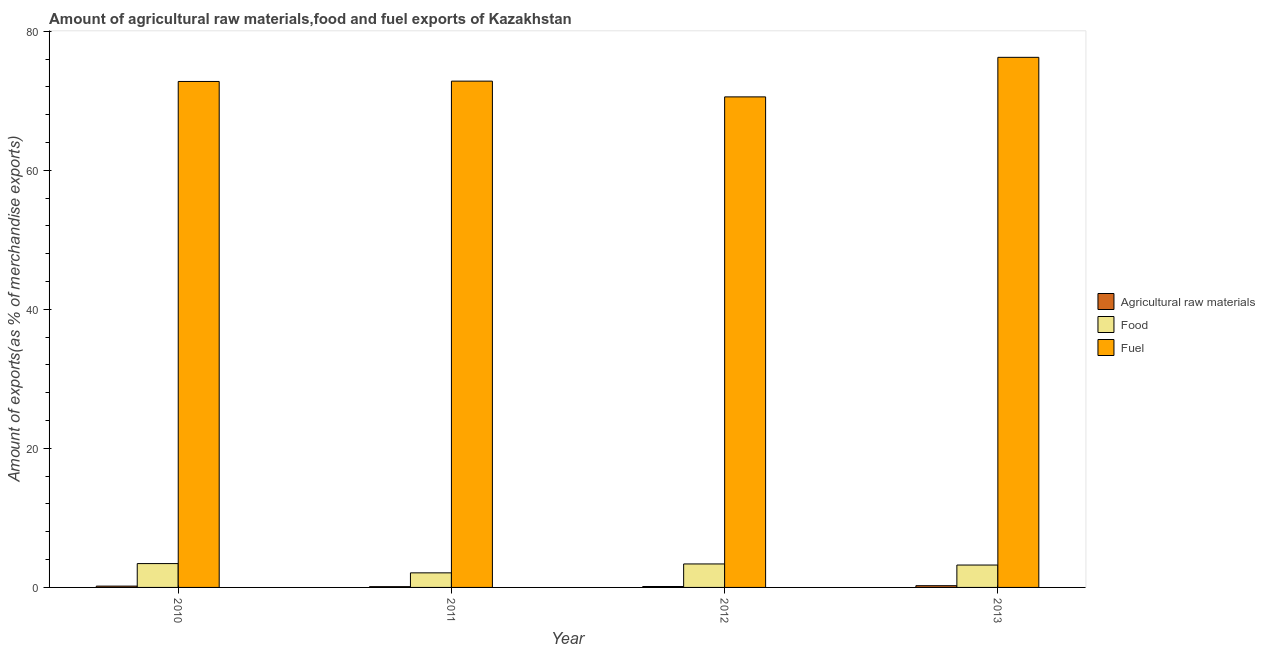How many different coloured bars are there?
Keep it short and to the point. 3. How many bars are there on the 3rd tick from the left?
Make the answer very short. 3. How many bars are there on the 3rd tick from the right?
Ensure brevity in your answer.  3. What is the percentage of food exports in 2012?
Provide a succinct answer. 3.38. Across all years, what is the maximum percentage of fuel exports?
Provide a succinct answer. 76.25. Across all years, what is the minimum percentage of food exports?
Make the answer very short. 2.1. In which year was the percentage of food exports maximum?
Your response must be concise. 2010. What is the total percentage of food exports in the graph?
Give a very brief answer. 12.12. What is the difference between the percentage of food exports in 2010 and that in 2013?
Keep it short and to the point. 0.21. What is the difference between the percentage of fuel exports in 2011 and the percentage of raw materials exports in 2012?
Your response must be concise. 2.27. What is the average percentage of food exports per year?
Provide a succinct answer. 3.03. In the year 2010, what is the difference between the percentage of fuel exports and percentage of raw materials exports?
Keep it short and to the point. 0. What is the ratio of the percentage of food exports in 2010 to that in 2011?
Offer a terse response. 1.64. Is the difference between the percentage of food exports in 2010 and 2013 greater than the difference between the percentage of fuel exports in 2010 and 2013?
Keep it short and to the point. No. What is the difference between the highest and the second highest percentage of food exports?
Your answer should be very brief. 0.05. What is the difference between the highest and the lowest percentage of fuel exports?
Give a very brief answer. 5.69. What does the 2nd bar from the left in 2010 represents?
Your response must be concise. Food. What does the 1st bar from the right in 2013 represents?
Make the answer very short. Fuel. Is it the case that in every year, the sum of the percentage of raw materials exports and percentage of food exports is greater than the percentage of fuel exports?
Your answer should be very brief. No. What is the difference between two consecutive major ticks on the Y-axis?
Your answer should be compact. 20. Are the values on the major ticks of Y-axis written in scientific E-notation?
Offer a terse response. No. Does the graph contain any zero values?
Ensure brevity in your answer.  No. Does the graph contain grids?
Keep it short and to the point. No. How are the legend labels stacked?
Your answer should be very brief. Vertical. What is the title of the graph?
Provide a short and direct response. Amount of agricultural raw materials,food and fuel exports of Kazakhstan. Does "Agricultural raw materials" appear as one of the legend labels in the graph?
Offer a terse response. Yes. What is the label or title of the X-axis?
Offer a very short reply. Year. What is the label or title of the Y-axis?
Offer a very short reply. Amount of exports(as % of merchandise exports). What is the Amount of exports(as % of merchandise exports) in Agricultural raw materials in 2010?
Ensure brevity in your answer.  0.19. What is the Amount of exports(as % of merchandise exports) in Food in 2010?
Give a very brief answer. 3.43. What is the Amount of exports(as % of merchandise exports) of Fuel in 2010?
Offer a terse response. 72.78. What is the Amount of exports(as % of merchandise exports) in Agricultural raw materials in 2011?
Your answer should be compact. 0.11. What is the Amount of exports(as % of merchandise exports) of Food in 2011?
Offer a very short reply. 2.1. What is the Amount of exports(as % of merchandise exports) in Fuel in 2011?
Give a very brief answer. 72.83. What is the Amount of exports(as % of merchandise exports) of Agricultural raw materials in 2012?
Your response must be concise. 0.13. What is the Amount of exports(as % of merchandise exports) in Food in 2012?
Your response must be concise. 3.38. What is the Amount of exports(as % of merchandise exports) of Fuel in 2012?
Offer a very short reply. 70.56. What is the Amount of exports(as % of merchandise exports) of Agricultural raw materials in 2013?
Your response must be concise. 0.25. What is the Amount of exports(as % of merchandise exports) in Food in 2013?
Your response must be concise. 3.22. What is the Amount of exports(as % of merchandise exports) of Fuel in 2013?
Provide a short and direct response. 76.25. Across all years, what is the maximum Amount of exports(as % of merchandise exports) in Agricultural raw materials?
Your answer should be very brief. 0.25. Across all years, what is the maximum Amount of exports(as % of merchandise exports) in Food?
Offer a terse response. 3.43. Across all years, what is the maximum Amount of exports(as % of merchandise exports) in Fuel?
Offer a terse response. 76.25. Across all years, what is the minimum Amount of exports(as % of merchandise exports) of Agricultural raw materials?
Provide a succinct answer. 0.11. Across all years, what is the minimum Amount of exports(as % of merchandise exports) of Food?
Offer a terse response. 2.1. Across all years, what is the minimum Amount of exports(as % of merchandise exports) in Fuel?
Your response must be concise. 70.56. What is the total Amount of exports(as % of merchandise exports) of Agricultural raw materials in the graph?
Keep it short and to the point. 0.68. What is the total Amount of exports(as % of merchandise exports) in Food in the graph?
Make the answer very short. 12.12. What is the total Amount of exports(as % of merchandise exports) in Fuel in the graph?
Your answer should be compact. 292.41. What is the difference between the Amount of exports(as % of merchandise exports) in Agricultural raw materials in 2010 and that in 2011?
Provide a succinct answer. 0.08. What is the difference between the Amount of exports(as % of merchandise exports) of Food in 2010 and that in 2011?
Your answer should be compact. 1.33. What is the difference between the Amount of exports(as % of merchandise exports) of Fuel in 2010 and that in 2011?
Offer a very short reply. -0.05. What is the difference between the Amount of exports(as % of merchandise exports) in Agricultural raw materials in 2010 and that in 2012?
Keep it short and to the point. 0.06. What is the difference between the Amount of exports(as % of merchandise exports) in Food in 2010 and that in 2012?
Offer a very short reply. 0.05. What is the difference between the Amount of exports(as % of merchandise exports) of Fuel in 2010 and that in 2012?
Ensure brevity in your answer.  2.22. What is the difference between the Amount of exports(as % of merchandise exports) in Agricultural raw materials in 2010 and that in 2013?
Keep it short and to the point. -0.06. What is the difference between the Amount of exports(as % of merchandise exports) in Food in 2010 and that in 2013?
Your response must be concise. 0.21. What is the difference between the Amount of exports(as % of merchandise exports) in Fuel in 2010 and that in 2013?
Offer a terse response. -3.47. What is the difference between the Amount of exports(as % of merchandise exports) in Agricultural raw materials in 2011 and that in 2012?
Give a very brief answer. -0.02. What is the difference between the Amount of exports(as % of merchandise exports) of Food in 2011 and that in 2012?
Your response must be concise. -1.28. What is the difference between the Amount of exports(as % of merchandise exports) of Fuel in 2011 and that in 2012?
Your response must be concise. 2.27. What is the difference between the Amount of exports(as % of merchandise exports) in Agricultural raw materials in 2011 and that in 2013?
Make the answer very short. -0.14. What is the difference between the Amount of exports(as % of merchandise exports) of Food in 2011 and that in 2013?
Make the answer very short. -1.12. What is the difference between the Amount of exports(as % of merchandise exports) of Fuel in 2011 and that in 2013?
Your answer should be compact. -3.42. What is the difference between the Amount of exports(as % of merchandise exports) in Agricultural raw materials in 2012 and that in 2013?
Give a very brief answer. -0.12. What is the difference between the Amount of exports(as % of merchandise exports) in Food in 2012 and that in 2013?
Give a very brief answer. 0.16. What is the difference between the Amount of exports(as % of merchandise exports) in Fuel in 2012 and that in 2013?
Ensure brevity in your answer.  -5.69. What is the difference between the Amount of exports(as % of merchandise exports) in Agricultural raw materials in 2010 and the Amount of exports(as % of merchandise exports) in Food in 2011?
Provide a short and direct response. -1.91. What is the difference between the Amount of exports(as % of merchandise exports) of Agricultural raw materials in 2010 and the Amount of exports(as % of merchandise exports) of Fuel in 2011?
Your answer should be compact. -72.64. What is the difference between the Amount of exports(as % of merchandise exports) of Food in 2010 and the Amount of exports(as % of merchandise exports) of Fuel in 2011?
Keep it short and to the point. -69.4. What is the difference between the Amount of exports(as % of merchandise exports) in Agricultural raw materials in 2010 and the Amount of exports(as % of merchandise exports) in Food in 2012?
Ensure brevity in your answer.  -3.19. What is the difference between the Amount of exports(as % of merchandise exports) of Agricultural raw materials in 2010 and the Amount of exports(as % of merchandise exports) of Fuel in 2012?
Make the answer very short. -70.37. What is the difference between the Amount of exports(as % of merchandise exports) in Food in 2010 and the Amount of exports(as % of merchandise exports) in Fuel in 2012?
Offer a very short reply. -67.13. What is the difference between the Amount of exports(as % of merchandise exports) in Agricultural raw materials in 2010 and the Amount of exports(as % of merchandise exports) in Food in 2013?
Ensure brevity in your answer.  -3.03. What is the difference between the Amount of exports(as % of merchandise exports) in Agricultural raw materials in 2010 and the Amount of exports(as % of merchandise exports) in Fuel in 2013?
Your response must be concise. -76.06. What is the difference between the Amount of exports(as % of merchandise exports) in Food in 2010 and the Amount of exports(as % of merchandise exports) in Fuel in 2013?
Make the answer very short. -72.82. What is the difference between the Amount of exports(as % of merchandise exports) in Agricultural raw materials in 2011 and the Amount of exports(as % of merchandise exports) in Food in 2012?
Provide a succinct answer. -3.27. What is the difference between the Amount of exports(as % of merchandise exports) in Agricultural raw materials in 2011 and the Amount of exports(as % of merchandise exports) in Fuel in 2012?
Provide a short and direct response. -70.45. What is the difference between the Amount of exports(as % of merchandise exports) in Food in 2011 and the Amount of exports(as % of merchandise exports) in Fuel in 2012?
Your response must be concise. -68.46. What is the difference between the Amount of exports(as % of merchandise exports) of Agricultural raw materials in 2011 and the Amount of exports(as % of merchandise exports) of Food in 2013?
Offer a terse response. -3.11. What is the difference between the Amount of exports(as % of merchandise exports) in Agricultural raw materials in 2011 and the Amount of exports(as % of merchandise exports) in Fuel in 2013?
Ensure brevity in your answer.  -76.14. What is the difference between the Amount of exports(as % of merchandise exports) of Food in 2011 and the Amount of exports(as % of merchandise exports) of Fuel in 2013?
Make the answer very short. -74.15. What is the difference between the Amount of exports(as % of merchandise exports) of Agricultural raw materials in 2012 and the Amount of exports(as % of merchandise exports) of Food in 2013?
Your answer should be compact. -3.09. What is the difference between the Amount of exports(as % of merchandise exports) of Agricultural raw materials in 2012 and the Amount of exports(as % of merchandise exports) of Fuel in 2013?
Offer a very short reply. -76.12. What is the difference between the Amount of exports(as % of merchandise exports) in Food in 2012 and the Amount of exports(as % of merchandise exports) in Fuel in 2013?
Offer a terse response. -72.87. What is the average Amount of exports(as % of merchandise exports) of Agricultural raw materials per year?
Provide a short and direct response. 0.17. What is the average Amount of exports(as % of merchandise exports) in Food per year?
Ensure brevity in your answer.  3.03. What is the average Amount of exports(as % of merchandise exports) of Fuel per year?
Make the answer very short. 73.1. In the year 2010, what is the difference between the Amount of exports(as % of merchandise exports) in Agricultural raw materials and Amount of exports(as % of merchandise exports) in Food?
Provide a succinct answer. -3.24. In the year 2010, what is the difference between the Amount of exports(as % of merchandise exports) of Agricultural raw materials and Amount of exports(as % of merchandise exports) of Fuel?
Provide a short and direct response. -72.59. In the year 2010, what is the difference between the Amount of exports(as % of merchandise exports) of Food and Amount of exports(as % of merchandise exports) of Fuel?
Provide a short and direct response. -69.35. In the year 2011, what is the difference between the Amount of exports(as % of merchandise exports) in Agricultural raw materials and Amount of exports(as % of merchandise exports) in Food?
Make the answer very short. -1.98. In the year 2011, what is the difference between the Amount of exports(as % of merchandise exports) of Agricultural raw materials and Amount of exports(as % of merchandise exports) of Fuel?
Provide a succinct answer. -72.71. In the year 2011, what is the difference between the Amount of exports(as % of merchandise exports) of Food and Amount of exports(as % of merchandise exports) of Fuel?
Your answer should be compact. -70.73. In the year 2012, what is the difference between the Amount of exports(as % of merchandise exports) in Agricultural raw materials and Amount of exports(as % of merchandise exports) in Food?
Your answer should be very brief. -3.25. In the year 2012, what is the difference between the Amount of exports(as % of merchandise exports) in Agricultural raw materials and Amount of exports(as % of merchandise exports) in Fuel?
Give a very brief answer. -70.43. In the year 2012, what is the difference between the Amount of exports(as % of merchandise exports) of Food and Amount of exports(as % of merchandise exports) of Fuel?
Ensure brevity in your answer.  -67.18. In the year 2013, what is the difference between the Amount of exports(as % of merchandise exports) in Agricultural raw materials and Amount of exports(as % of merchandise exports) in Food?
Keep it short and to the point. -2.97. In the year 2013, what is the difference between the Amount of exports(as % of merchandise exports) of Agricultural raw materials and Amount of exports(as % of merchandise exports) of Fuel?
Offer a very short reply. -76. In the year 2013, what is the difference between the Amount of exports(as % of merchandise exports) in Food and Amount of exports(as % of merchandise exports) in Fuel?
Keep it short and to the point. -73.03. What is the ratio of the Amount of exports(as % of merchandise exports) of Agricultural raw materials in 2010 to that in 2011?
Ensure brevity in your answer.  1.69. What is the ratio of the Amount of exports(as % of merchandise exports) of Food in 2010 to that in 2011?
Keep it short and to the point. 1.64. What is the ratio of the Amount of exports(as % of merchandise exports) in Agricultural raw materials in 2010 to that in 2012?
Your response must be concise. 1.43. What is the ratio of the Amount of exports(as % of merchandise exports) in Food in 2010 to that in 2012?
Your answer should be compact. 1.02. What is the ratio of the Amount of exports(as % of merchandise exports) in Fuel in 2010 to that in 2012?
Make the answer very short. 1.03. What is the ratio of the Amount of exports(as % of merchandise exports) of Agricultural raw materials in 2010 to that in 2013?
Keep it short and to the point. 0.76. What is the ratio of the Amount of exports(as % of merchandise exports) in Food in 2010 to that in 2013?
Provide a succinct answer. 1.07. What is the ratio of the Amount of exports(as % of merchandise exports) in Fuel in 2010 to that in 2013?
Your answer should be very brief. 0.95. What is the ratio of the Amount of exports(as % of merchandise exports) in Agricultural raw materials in 2011 to that in 2012?
Offer a very short reply. 0.85. What is the ratio of the Amount of exports(as % of merchandise exports) of Food in 2011 to that in 2012?
Your answer should be compact. 0.62. What is the ratio of the Amount of exports(as % of merchandise exports) in Fuel in 2011 to that in 2012?
Offer a very short reply. 1.03. What is the ratio of the Amount of exports(as % of merchandise exports) in Agricultural raw materials in 2011 to that in 2013?
Give a very brief answer. 0.45. What is the ratio of the Amount of exports(as % of merchandise exports) of Food in 2011 to that in 2013?
Make the answer very short. 0.65. What is the ratio of the Amount of exports(as % of merchandise exports) in Fuel in 2011 to that in 2013?
Make the answer very short. 0.96. What is the ratio of the Amount of exports(as % of merchandise exports) of Agricultural raw materials in 2012 to that in 2013?
Your response must be concise. 0.53. What is the ratio of the Amount of exports(as % of merchandise exports) in Food in 2012 to that in 2013?
Your answer should be compact. 1.05. What is the ratio of the Amount of exports(as % of merchandise exports) of Fuel in 2012 to that in 2013?
Offer a terse response. 0.93. What is the difference between the highest and the second highest Amount of exports(as % of merchandise exports) of Agricultural raw materials?
Your response must be concise. 0.06. What is the difference between the highest and the second highest Amount of exports(as % of merchandise exports) of Food?
Give a very brief answer. 0.05. What is the difference between the highest and the second highest Amount of exports(as % of merchandise exports) in Fuel?
Ensure brevity in your answer.  3.42. What is the difference between the highest and the lowest Amount of exports(as % of merchandise exports) in Agricultural raw materials?
Your answer should be very brief. 0.14. What is the difference between the highest and the lowest Amount of exports(as % of merchandise exports) of Food?
Keep it short and to the point. 1.33. What is the difference between the highest and the lowest Amount of exports(as % of merchandise exports) in Fuel?
Keep it short and to the point. 5.69. 